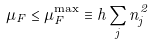Convert formula to latex. <formula><loc_0><loc_0><loc_500><loc_500>\mu _ { F } \leq \mu _ { F } ^ { \max } \equiv h \sum _ { j } n _ { j } ^ { 2 }</formula> 